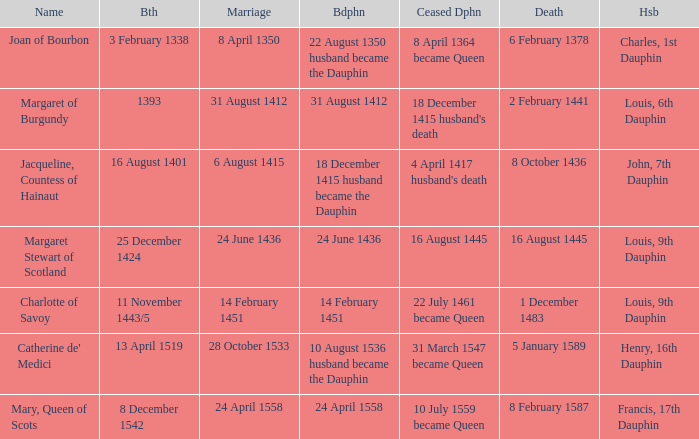Who has a birth of 16 august 1401? Jacqueline, Countess of Hainaut. 